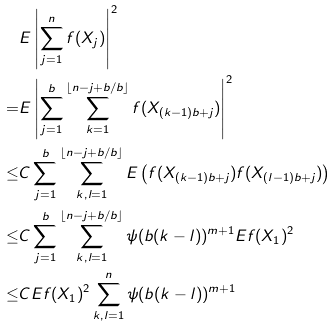<formula> <loc_0><loc_0><loc_500><loc_500>& E \left | \sum _ { j = 1 } ^ { n } f ( X _ { j } ) \right | ^ { 2 } \\ = & E \left | \sum _ { j = 1 } ^ { b } \sum _ { k = 1 } ^ { \lfloor n - j + b / b \rfloor } f ( X _ { ( k - 1 ) b + j } ) \right | ^ { 2 } \\ \leq & C \sum _ { j = 1 } ^ { b } \sum _ { k , l = 1 } ^ { \lfloor n - j + b / b \rfloor } E \left ( f ( X _ { ( k - 1 ) b + j } ) f ( X _ { ( l - 1 ) b + j } ) \right ) \\ \leq & C \sum _ { j = 1 } ^ { b } \sum _ { k , l = 1 } ^ { \lfloor n - j + b / b \rfloor } \psi ( b ( k - l ) ) ^ { m + 1 } E f ( X _ { 1 } ) ^ { 2 } \\ \leq & C E f ( X _ { 1 } ) ^ { 2 } \sum _ { k , l = 1 } ^ { n } \psi ( b ( k - l ) ) ^ { m + 1 } \\</formula> 